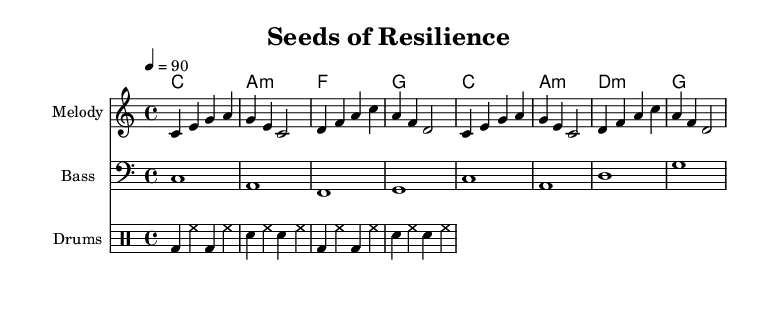What is the key signature of this music? The key signature is C major, which has no sharps or flats indicated. This is typically seen at the beginning of the piece.
Answer: C major What is the time signature of this music? The time signature is 4/4, which means there are four beats per measure. This can be found at the beginning of the sheet music next to the key signature.
Answer: 4/4 What is the tempo of this piece? The tempo is set at quarter note = 90, meaning the rhythm pace is moderate. The tempo marking is written at the start of the piece, showing how fast the music should be played.
Answer: 90 How many measures are in the melody? The melody consists of 8 measures, as you can see by counting the bars in the melody staff. Each measure is separated by vertical lines.
Answer: 8 What is the primary theme of the lyrics? The lyrics focus on themes of growth and perseverance in organic farming, as they mention planting seeds and overcoming challenges. By analyzing the text of the lyrics, we can see the inspirational message.
Answer: Growth and perseverance What type of musical sections can be identified in this rap piece? The rap consists of a repetitive structure with verses, which is typical for hip-hop and focuses on delivering a message through lyrics. This can be deduced from the way the lyrics repeat and share a common flow.
Answer: Verses 